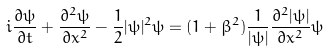Convert formula to latex. <formula><loc_0><loc_0><loc_500><loc_500>i \frac { \partial \psi } { \partial t } + \frac { \partial ^ { 2 } \psi } { \partial x ^ { 2 } } - \frac { 1 } { 2 } | \psi | ^ { 2 } \psi = ( 1 + \beta ^ { 2 } ) \frac { 1 } { | \psi | } \frac { \partial ^ { 2 } | \psi | } { \partial x ^ { 2 } } \psi</formula> 